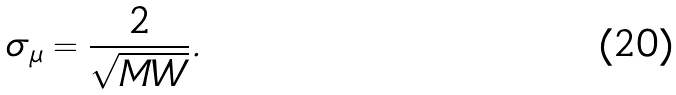<formula> <loc_0><loc_0><loc_500><loc_500>\sigma _ { \mu } = \frac { 2 } { \sqrt { M W } } .</formula> 